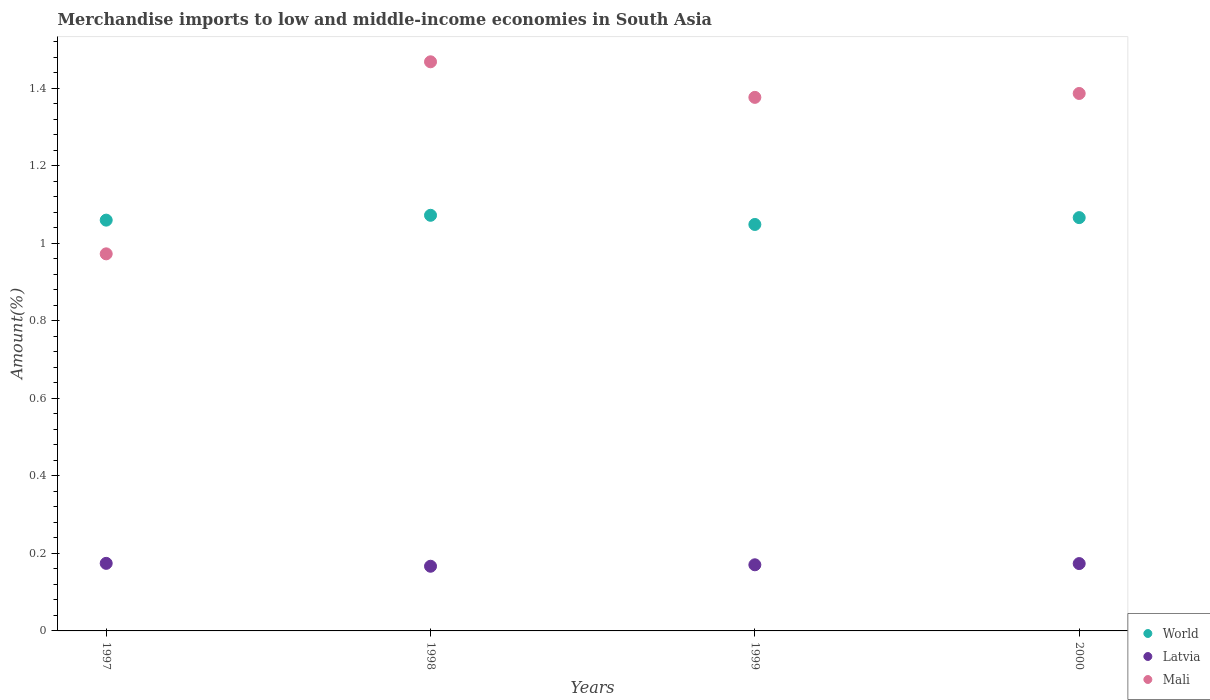Is the number of dotlines equal to the number of legend labels?
Your response must be concise. Yes. What is the percentage of amount earned from merchandise imports in Latvia in 1997?
Give a very brief answer. 0.17. Across all years, what is the maximum percentage of amount earned from merchandise imports in World?
Your answer should be compact. 1.07. Across all years, what is the minimum percentage of amount earned from merchandise imports in Mali?
Ensure brevity in your answer.  0.97. What is the total percentage of amount earned from merchandise imports in Mali in the graph?
Offer a terse response. 5.2. What is the difference between the percentage of amount earned from merchandise imports in Mali in 1999 and that in 2000?
Provide a succinct answer. -0.01. What is the difference between the percentage of amount earned from merchandise imports in World in 1997 and the percentage of amount earned from merchandise imports in Latvia in 1999?
Offer a terse response. 0.89. What is the average percentage of amount earned from merchandise imports in Mali per year?
Provide a succinct answer. 1.3. In the year 1997, what is the difference between the percentage of amount earned from merchandise imports in Latvia and percentage of amount earned from merchandise imports in Mali?
Your response must be concise. -0.8. What is the ratio of the percentage of amount earned from merchandise imports in World in 1997 to that in 2000?
Offer a terse response. 0.99. Is the percentage of amount earned from merchandise imports in Latvia in 1999 less than that in 2000?
Provide a short and direct response. Yes. What is the difference between the highest and the second highest percentage of amount earned from merchandise imports in Latvia?
Provide a succinct answer. 0. What is the difference between the highest and the lowest percentage of amount earned from merchandise imports in Latvia?
Give a very brief answer. 0.01. In how many years, is the percentage of amount earned from merchandise imports in World greater than the average percentage of amount earned from merchandise imports in World taken over all years?
Provide a succinct answer. 2. Is the sum of the percentage of amount earned from merchandise imports in Latvia in 1997 and 2000 greater than the maximum percentage of amount earned from merchandise imports in Mali across all years?
Give a very brief answer. No. Does the percentage of amount earned from merchandise imports in World monotonically increase over the years?
Give a very brief answer. No. How many dotlines are there?
Ensure brevity in your answer.  3. Are the values on the major ticks of Y-axis written in scientific E-notation?
Keep it short and to the point. No. What is the title of the graph?
Your response must be concise. Merchandise imports to low and middle-income economies in South Asia. Does "Panama" appear as one of the legend labels in the graph?
Ensure brevity in your answer.  No. What is the label or title of the X-axis?
Your answer should be compact. Years. What is the label or title of the Y-axis?
Ensure brevity in your answer.  Amount(%). What is the Amount(%) of World in 1997?
Offer a very short reply. 1.06. What is the Amount(%) in Latvia in 1997?
Offer a terse response. 0.17. What is the Amount(%) of Mali in 1997?
Provide a succinct answer. 0.97. What is the Amount(%) in World in 1998?
Your response must be concise. 1.07. What is the Amount(%) of Latvia in 1998?
Offer a very short reply. 0.17. What is the Amount(%) of Mali in 1998?
Provide a succinct answer. 1.47. What is the Amount(%) in World in 1999?
Your answer should be compact. 1.05. What is the Amount(%) in Latvia in 1999?
Your answer should be compact. 0.17. What is the Amount(%) in Mali in 1999?
Your answer should be very brief. 1.38. What is the Amount(%) in World in 2000?
Your answer should be very brief. 1.07. What is the Amount(%) in Latvia in 2000?
Keep it short and to the point. 0.17. What is the Amount(%) in Mali in 2000?
Your response must be concise. 1.39. Across all years, what is the maximum Amount(%) in World?
Your answer should be very brief. 1.07. Across all years, what is the maximum Amount(%) of Latvia?
Offer a very short reply. 0.17. Across all years, what is the maximum Amount(%) of Mali?
Offer a very short reply. 1.47. Across all years, what is the minimum Amount(%) in World?
Your response must be concise. 1.05. Across all years, what is the minimum Amount(%) in Latvia?
Your answer should be compact. 0.17. Across all years, what is the minimum Amount(%) in Mali?
Your answer should be compact. 0.97. What is the total Amount(%) of World in the graph?
Provide a succinct answer. 4.25. What is the total Amount(%) in Latvia in the graph?
Your answer should be compact. 0.69. What is the total Amount(%) of Mali in the graph?
Give a very brief answer. 5.2. What is the difference between the Amount(%) of World in 1997 and that in 1998?
Offer a terse response. -0.01. What is the difference between the Amount(%) in Latvia in 1997 and that in 1998?
Your answer should be very brief. 0.01. What is the difference between the Amount(%) in Mali in 1997 and that in 1998?
Provide a succinct answer. -0.5. What is the difference between the Amount(%) in World in 1997 and that in 1999?
Give a very brief answer. 0.01. What is the difference between the Amount(%) in Latvia in 1997 and that in 1999?
Offer a very short reply. 0. What is the difference between the Amount(%) of Mali in 1997 and that in 1999?
Your answer should be very brief. -0.4. What is the difference between the Amount(%) of World in 1997 and that in 2000?
Your answer should be very brief. -0.01. What is the difference between the Amount(%) in Latvia in 1997 and that in 2000?
Offer a terse response. 0. What is the difference between the Amount(%) in Mali in 1997 and that in 2000?
Your response must be concise. -0.41. What is the difference between the Amount(%) of World in 1998 and that in 1999?
Provide a short and direct response. 0.02. What is the difference between the Amount(%) of Latvia in 1998 and that in 1999?
Your answer should be compact. -0. What is the difference between the Amount(%) of Mali in 1998 and that in 1999?
Provide a short and direct response. 0.09. What is the difference between the Amount(%) in World in 1998 and that in 2000?
Ensure brevity in your answer.  0.01. What is the difference between the Amount(%) of Latvia in 1998 and that in 2000?
Make the answer very short. -0.01. What is the difference between the Amount(%) of Mali in 1998 and that in 2000?
Your response must be concise. 0.08. What is the difference between the Amount(%) of World in 1999 and that in 2000?
Ensure brevity in your answer.  -0.02. What is the difference between the Amount(%) in Latvia in 1999 and that in 2000?
Your response must be concise. -0. What is the difference between the Amount(%) of Mali in 1999 and that in 2000?
Ensure brevity in your answer.  -0.01. What is the difference between the Amount(%) in World in 1997 and the Amount(%) in Latvia in 1998?
Offer a very short reply. 0.89. What is the difference between the Amount(%) in World in 1997 and the Amount(%) in Mali in 1998?
Your answer should be very brief. -0.41. What is the difference between the Amount(%) in Latvia in 1997 and the Amount(%) in Mali in 1998?
Offer a very short reply. -1.29. What is the difference between the Amount(%) of World in 1997 and the Amount(%) of Latvia in 1999?
Ensure brevity in your answer.  0.89. What is the difference between the Amount(%) in World in 1997 and the Amount(%) in Mali in 1999?
Make the answer very short. -0.32. What is the difference between the Amount(%) in Latvia in 1997 and the Amount(%) in Mali in 1999?
Your answer should be very brief. -1.2. What is the difference between the Amount(%) of World in 1997 and the Amount(%) of Latvia in 2000?
Ensure brevity in your answer.  0.89. What is the difference between the Amount(%) in World in 1997 and the Amount(%) in Mali in 2000?
Your response must be concise. -0.33. What is the difference between the Amount(%) of Latvia in 1997 and the Amount(%) of Mali in 2000?
Ensure brevity in your answer.  -1.21. What is the difference between the Amount(%) of World in 1998 and the Amount(%) of Latvia in 1999?
Make the answer very short. 0.9. What is the difference between the Amount(%) of World in 1998 and the Amount(%) of Mali in 1999?
Your response must be concise. -0.3. What is the difference between the Amount(%) in Latvia in 1998 and the Amount(%) in Mali in 1999?
Offer a very short reply. -1.21. What is the difference between the Amount(%) of World in 1998 and the Amount(%) of Latvia in 2000?
Your response must be concise. 0.9. What is the difference between the Amount(%) of World in 1998 and the Amount(%) of Mali in 2000?
Keep it short and to the point. -0.31. What is the difference between the Amount(%) of Latvia in 1998 and the Amount(%) of Mali in 2000?
Your answer should be very brief. -1.22. What is the difference between the Amount(%) of World in 1999 and the Amount(%) of Mali in 2000?
Give a very brief answer. -0.34. What is the difference between the Amount(%) in Latvia in 1999 and the Amount(%) in Mali in 2000?
Ensure brevity in your answer.  -1.22. What is the average Amount(%) in World per year?
Offer a very short reply. 1.06. What is the average Amount(%) in Latvia per year?
Your answer should be very brief. 0.17. What is the average Amount(%) of Mali per year?
Give a very brief answer. 1.3. In the year 1997, what is the difference between the Amount(%) of World and Amount(%) of Latvia?
Your response must be concise. 0.89. In the year 1997, what is the difference between the Amount(%) in World and Amount(%) in Mali?
Your response must be concise. 0.09. In the year 1997, what is the difference between the Amount(%) of Latvia and Amount(%) of Mali?
Provide a short and direct response. -0.8. In the year 1998, what is the difference between the Amount(%) in World and Amount(%) in Latvia?
Offer a very short reply. 0.91. In the year 1998, what is the difference between the Amount(%) of World and Amount(%) of Mali?
Provide a succinct answer. -0.4. In the year 1998, what is the difference between the Amount(%) of Latvia and Amount(%) of Mali?
Make the answer very short. -1.3. In the year 1999, what is the difference between the Amount(%) of World and Amount(%) of Latvia?
Your answer should be very brief. 0.88. In the year 1999, what is the difference between the Amount(%) in World and Amount(%) in Mali?
Keep it short and to the point. -0.33. In the year 1999, what is the difference between the Amount(%) in Latvia and Amount(%) in Mali?
Ensure brevity in your answer.  -1.21. In the year 2000, what is the difference between the Amount(%) of World and Amount(%) of Latvia?
Make the answer very short. 0.89. In the year 2000, what is the difference between the Amount(%) of World and Amount(%) of Mali?
Offer a terse response. -0.32. In the year 2000, what is the difference between the Amount(%) of Latvia and Amount(%) of Mali?
Offer a terse response. -1.21. What is the ratio of the Amount(%) in World in 1997 to that in 1998?
Your response must be concise. 0.99. What is the ratio of the Amount(%) in Latvia in 1997 to that in 1998?
Keep it short and to the point. 1.04. What is the ratio of the Amount(%) in Mali in 1997 to that in 1998?
Give a very brief answer. 0.66. What is the ratio of the Amount(%) in World in 1997 to that in 1999?
Offer a terse response. 1.01. What is the ratio of the Amount(%) of Latvia in 1997 to that in 1999?
Keep it short and to the point. 1.02. What is the ratio of the Amount(%) of Mali in 1997 to that in 1999?
Provide a short and direct response. 0.71. What is the ratio of the Amount(%) in World in 1997 to that in 2000?
Provide a succinct answer. 0.99. What is the ratio of the Amount(%) of Latvia in 1997 to that in 2000?
Make the answer very short. 1. What is the ratio of the Amount(%) of Mali in 1997 to that in 2000?
Your answer should be compact. 0.7. What is the ratio of the Amount(%) in World in 1998 to that in 1999?
Your answer should be compact. 1.02. What is the ratio of the Amount(%) of Latvia in 1998 to that in 1999?
Provide a short and direct response. 0.98. What is the ratio of the Amount(%) of Mali in 1998 to that in 1999?
Keep it short and to the point. 1.07. What is the ratio of the Amount(%) in World in 1998 to that in 2000?
Give a very brief answer. 1.01. What is the ratio of the Amount(%) in Latvia in 1998 to that in 2000?
Keep it short and to the point. 0.96. What is the ratio of the Amount(%) of Mali in 1998 to that in 2000?
Your answer should be very brief. 1.06. What is the ratio of the Amount(%) in World in 1999 to that in 2000?
Make the answer very short. 0.98. What is the ratio of the Amount(%) of Latvia in 1999 to that in 2000?
Provide a succinct answer. 0.98. What is the ratio of the Amount(%) in Mali in 1999 to that in 2000?
Ensure brevity in your answer.  0.99. What is the difference between the highest and the second highest Amount(%) in World?
Give a very brief answer. 0.01. What is the difference between the highest and the second highest Amount(%) of Latvia?
Provide a short and direct response. 0. What is the difference between the highest and the second highest Amount(%) of Mali?
Keep it short and to the point. 0.08. What is the difference between the highest and the lowest Amount(%) of World?
Ensure brevity in your answer.  0.02. What is the difference between the highest and the lowest Amount(%) in Latvia?
Offer a terse response. 0.01. What is the difference between the highest and the lowest Amount(%) of Mali?
Give a very brief answer. 0.5. 